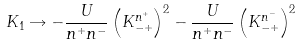<formula> <loc_0><loc_0><loc_500><loc_500>K _ { 1 } \rightarrow - \frac { U } { n ^ { + } n ^ { - } } \left ( K _ { - + } ^ { n ^ { + } } \right ) ^ { 2 } - \frac { U } { n ^ { + } n ^ { - } } \left ( K _ { - + } ^ { n ^ { - } } \right ) ^ { 2 }</formula> 